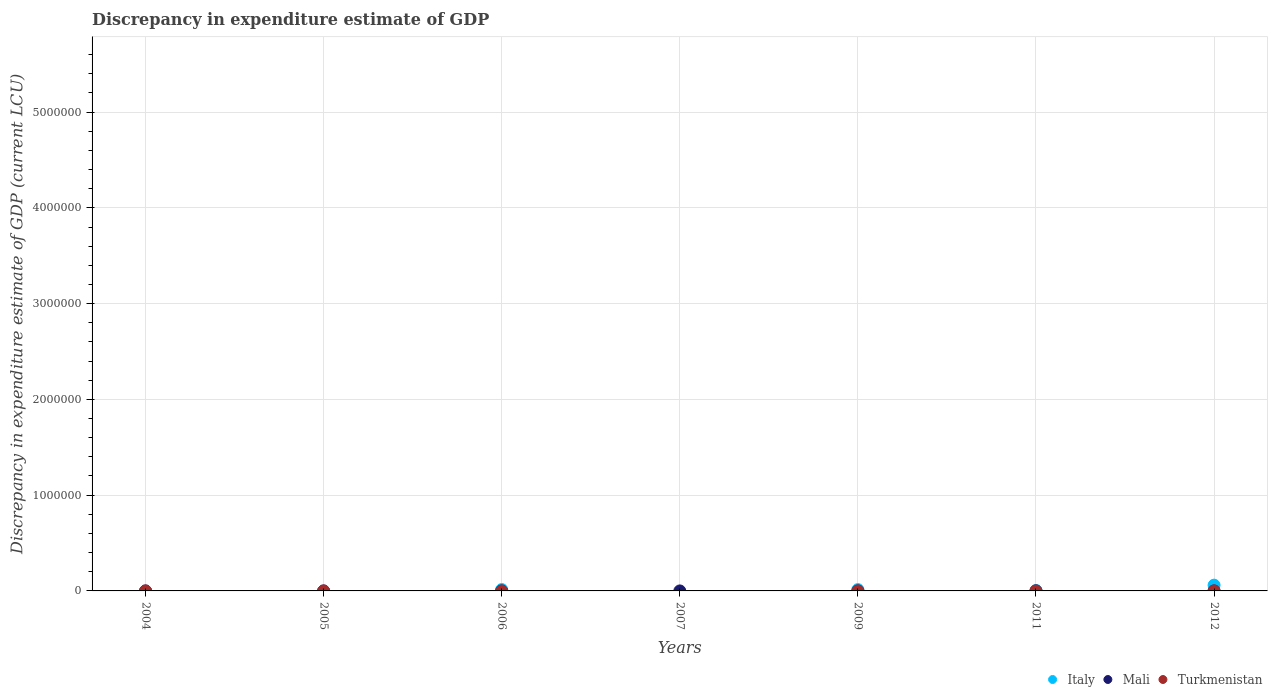Is the number of dotlines equal to the number of legend labels?
Your answer should be very brief. No. What is the discrepancy in expenditure estimate of GDP in Italy in 2012?
Your response must be concise. 6.02e+04. Across all years, what is the maximum discrepancy in expenditure estimate of GDP in Mali?
Provide a succinct answer. 0.01. Across all years, what is the minimum discrepancy in expenditure estimate of GDP in Mali?
Provide a succinct answer. 0. In which year was the discrepancy in expenditure estimate of GDP in Mali maximum?
Ensure brevity in your answer.  2011. What is the total discrepancy in expenditure estimate of GDP in Italy in the graph?
Your answer should be compact. 9.27e+04. What is the difference between the discrepancy in expenditure estimate of GDP in Mali in 2006 and that in 2011?
Offer a terse response. -0.01. What is the difference between the discrepancy in expenditure estimate of GDP in Mali in 2011 and the discrepancy in expenditure estimate of GDP in Italy in 2007?
Give a very brief answer. 0.01. What is the average discrepancy in expenditure estimate of GDP in Turkmenistan per year?
Make the answer very short. 5.66142857142857e-5. In the year 2009, what is the difference between the discrepancy in expenditure estimate of GDP in Italy and discrepancy in expenditure estimate of GDP in Turkmenistan?
Ensure brevity in your answer.  1.36e+04. In how many years, is the discrepancy in expenditure estimate of GDP in Turkmenistan greater than 3400000 LCU?
Your response must be concise. 0. What is the ratio of the discrepancy in expenditure estimate of GDP in Italy in 2011 to that in 2012?
Provide a succinct answer. 0.08. Is the discrepancy in expenditure estimate of GDP in Turkmenistan in 2006 less than that in 2009?
Provide a short and direct response. No. What is the difference between the highest and the second highest discrepancy in expenditure estimate of GDP in Italy?
Offer a terse response. 4.60e+04. What is the difference between the highest and the lowest discrepancy in expenditure estimate of GDP in Italy?
Offer a terse response. 6.02e+04. Does the discrepancy in expenditure estimate of GDP in Italy monotonically increase over the years?
Make the answer very short. No. Is the discrepancy in expenditure estimate of GDP in Mali strictly greater than the discrepancy in expenditure estimate of GDP in Turkmenistan over the years?
Give a very brief answer. No. Is the discrepancy in expenditure estimate of GDP in Mali strictly less than the discrepancy in expenditure estimate of GDP in Italy over the years?
Your response must be concise. No. How many dotlines are there?
Keep it short and to the point. 3. How many years are there in the graph?
Give a very brief answer. 7. Are the values on the major ticks of Y-axis written in scientific E-notation?
Your answer should be compact. No. Does the graph contain grids?
Provide a succinct answer. Yes. How are the legend labels stacked?
Make the answer very short. Horizontal. What is the title of the graph?
Offer a very short reply. Discrepancy in expenditure estimate of GDP. What is the label or title of the X-axis?
Offer a very short reply. Years. What is the label or title of the Y-axis?
Offer a very short reply. Discrepancy in expenditure estimate of GDP (current LCU). What is the Discrepancy in expenditure estimate of GDP (current LCU) in Italy in 2004?
Provide a short and direct response. 0. What is the Discrepancy in expenditure estimate of GDP (current LCU) in Turkmenistan in 2004?
Provide a succinct answer. 0. What is the Discrepancy in expenditure estimate of GDP (current LCU) of Mali in 2005?
Your answer should be compact. 0. What is the Discrepancy in expenditure estimate of GDP (current LCU) of Turkmenistan in 2005?
Provide a short and direct response. 5e-7. What is the Discrepancy in expenditure estimate of GDP (current LCU) of Italy in 2006?
Ensure brevity in your answer.  1.42e+04. What is the Discrepancy in expenditure estimate of GDP (current LCU) of Mali in 2006?
Your answer should be compact. 0. What is the Discrepancy in expenditure estimate of GDP (current LCU) of Turkmenistan in 2006?
Offer a terse response. 9.91e-5. What is the Discrepancy in expenditure estimate of GDP (current LCU) in Italy in 2007?
Give a very brief answer. 0. What is the Discrepancy in expenditure estimate of GDP (current LCU) in Mali in 2007?
Offer a terse response. 0. What is the Discrepancy in expenditure estimate of GDP (current LCU) in Turkmenistan in 2007?
Provide a succinct answer. 0. What is the Discrepancy in expenditure estimate of GDP (current LCU) in Italy in 2009?
Give a very brief answer. 1.36e+04. What is the Discrepancy in expenditure estimate of GDP (current LCU) in Mali in 2009?
Provide a short and direct response. 0. What is the Discrepancy in expenditure estimate of GDP (current LCU) in Turkmenistan in 2009?
Offer a terse response. 9.9e-5. What is the Discrepancy in expenditure estimate of GDP (current LCU) of Italy in 2011?
Ensure brevity in your answer.  4700. What is the Discrepancy in expenditure estimate of GDP (current LCU) of Mali in 2011?
Provide a short and direct response. 0.01. What is the Discrepancy in expenditure estimate of GDP (current LCU) of Turkmenistan in 2011?
Provide a succinct answer. 9.76e-5. What is the Discrepancy in expenditure estimate of GDP (current LCU) of Italy in 2012?
Ensure brevity in your answer.  6.02e+04. What is the Discrepancy in expenditure estimate of GDP (current LCU) of Turkmenistan in 2012?
Your response must be concise. 0. Across all years, what is the maximum Discrepancy in expenditure estimate of GDP (current LCU) in Italy?
Give a very brief answer. 6.02e+04. Across all years, what is the maximum Discrepancy in expenditure estimate of GDP (current LCU) of Mali?
Ensure brevity in your answer.  0.01. Across all years, what is the maximum Discrepancy in expenditure estimate of GDP (current LCU) in Turkmenistan?
Your response must be concise. 0. Across all years, what is the minimum Discrepancy in expenditure estimate of GDP (current LCU) in Mali?
Your answer should be very brief. 0. What is the total Discrepancy in expenditure estimate of GDP (current LCU) in Italy in the graph?
Provide a short and direct response. 9.27e+04. What is the total Discrepancy in expenditure estimate of GDP (current LCU) in Mali in the graph?
Offer a terse response. 0.02. What is the difference between the Discrepancy in expenditure estimate of GDP (current LCU) of Turkmenistan in 2004 and that in 2005?
Offer a terse response. 0. What is the difference between the Discrepancy in expenditure estimate of GDP (current LCU) of Turkmenistan in 2004 and that in 2011?
Make the answer very short. 0. What is the difference between the Discrepancy in expenditure estimate of GDP (current LCU) in Mali in 2005 and that in 2006?
Offer a terse response. 0. What is the difference between the Discrepancy in expenditure estimate of GDP (current LCU) in Turkmenistan in 2005 and that in 2006?
Ensure brevity in your answer.  -0. What is the difference between the Discrepancy in expenditure estimate of GDP (current LCU) in Mali in 2005 and that in 2007?
Keep it short and to the point. 0. What is the difference between the Discrepancy in expenditure estimate of GDP (current LCU) of Turkmenistan in 2005 and that in 2009?
Offer a very short reply. -0. What is the difference between the Discrepancy in expenditure estimate of GDP (current LCU) of Mali in 2005 and that in 2011?
Your response must be concise. -0. What is the difference between the Discrepancy in expenditure estimate of GDP (current LCU) in Turkmenistan in 2005 and that in 2011?
Your response must be concise. -0. What is the difference between the Discrepancy in expenditure estimate of GDP (current LCU) in Mali in 2006 and that in 2007?
Your answer should be very brief. 0. What is the difference between the Discrepancy in expenditure estimate of GDP (current LCU) in Italy in 2006 and that in 2009?
Your answer should be compact. 600. What is the difference between the Discrepancy in expenditure estimate of GDP (current LCU) of Turkmenistan in 2006 and that in 2009?
Offer a terse response. 0. What is the difference between the Discrepancy in expenditure estimate of GDP (current LCU) of Italy in 2006 and that in 2011?
Provide a succinct answer. 9500. What is the difference between the Discrepancy in expenditure estimate of GDP (current LCU) in Mali in 2006 and that in 2011?
Your answer should be very brief. -0.01. What is the difference between the Discrepancy in expenditure estimate of GDP (current LCU) in Italy in 2006 and that in 2012?
Your response must be concise. -4.60e+04. What is the difference between the Discrepancy in expenditure estimate of GDP (current LCU) of Mali in 2007 and that in 2011?
Give a very brief answer. -0.01. What is the difference between the Discrepancy in expenditure estimate of GDP (current LCU) in Italy in 2009 and that in 2011?
Your response must be concise. 8900. What is the difference between the Discrepancy in expenditure estimate of GDP (current LCU) of Turkmenistan in 2009 and that in 2011?
Make the answer very short. 0. What is the difference between the Discrepancy in expenditure estimate of GDP (current LCU) of Italy in 2009 and that in 2012?
Your answer should be very brief. -4.66e+04. What is the difference between the Discrepancy in expenditure estimate of GDP (current LCU) of Italy in 2011 and that in 2012?
Keep it short and to the point. -5.55e+04. What is the difference between the Discrepancy in expenditure estimate of GDP (current LCU) in Mali in 2005 and the Discrepancy in expenditure estimate of GDP (current LCU) in Turkmenistan in 2006?
Your answer should be compact. 0. What is the difference between the Discrepancy in expenditure estimate of GDP (current LCU) of Mali in 2005 and the Discrepancy in expenditure estimate of GDP (current LCU) of Turkmenistan in 2009?
Provide a succinct answer. 0. What is the difference between the Discrepancy in expenditure estimate of GDP (current LCU) of Mali in 2005 and the Discrepancy in expenditure estimate of GDP (current LCU) of Turkmenistan in 2011?
Provide a succinct answer. 0. What is the difference between the Discrepancy in expenditure estimate of GDP (current LCU) in Italy in 2006 and the Discrepancy in expenditure estimate of GDP (current LCU) in Mali in 2007?
Keep it short and to the point. 1.42e+04. What is the difference between the Discrepancy in expenditure estimate of GDP (current LCU) of Italy in 2006 and the Discrepancy in expenditure estimate of GDP (current LCU) of Turkmenistan in 2009?
Your response must be concise. 1.42e+04. What is the difference between the Discrepancy in expenditure estimate of GDP (current LCU) of Mali in 2006 and the Discrepancy in expenditure estimate of GDP (current LCU) of Turkmenistan in 2009?
Offer a terse response. 0. What is the difference between the Discrepancy in expenditure estimate of GDP (current LCU) of Italy in 2006 and the Discrepancy in expenditure estimate of GDP (current LCU) of Mali in 2011?
Ensure brevity in your answer.  1.42e+04. What is the difference between the Discrepancy in expenditure estimate of GDP (current LCU) in Italy in 2006 and the Discrepancy in expenditure estimate of GDP (current LCU) in Turkmenistan in 2011?
Give a very brief answer. 1.42e+04. What is the difference between the Discrepancy in expenditure estimate of GDP (current LCU) in Mali in 2006 and the Discrepancy in expenditure estimate of GDP (current LCU) in Turkmenistan in 2011?
Offer a terse response. 0. What is the difference between the Discrepancy in expenditure estimate of GDP (current LCU) of Mali in 2007 and the Discrepancy in expenditure estimate of GDP (current LCU) of Turkmenistan in 2009?
Provide a short and direct response. 0. What is the difference between the Discrepancy in expenditure estimate of GDP (current LCU) of Mali in 2007 and the Discrepancy in expenditure estimate of GDP (current LCU) of Turkmenistan in 2011?
Your answer should be very brief. 0. What is the difference between the Discrepancy in expenditure estimate of GDP (current LCU) of Italy in 2009 and the Discrepancy in expenditure estimate of GDP (current LCU) of Mali in 2011?
Give a very brief answer. 1.36e+04. What is the difference between the Discrepancy in expenditure estimate of GDP (current LCU) of Italy in 2009 and the Discrepancy in expenditure estimate of GDP (current LCU) of Turkmenistan in 2011?
Offer a very short reply. 1.36e+04. What is the average Discrepancy in expenditure estimate of GDP (current LCU) in Italy per year?
Offer a terse response. 1.32e+04. What is the average Discrepancy in expenditure estimate of GDP (current LCU) of Mali per year?
Your answer should be very brief. 0. What is the average Discrepancy in expenditure estimate of GDP (current LCU) in Turkmenistan per year?
Keep it short and to the point. 0. In the year 2005, what is the difference between the Discrepancy in expenditure estimate of GDP (current LCU) in Mali and Discrepancy in expenditure estimate of GDP (current LCU) in Turkmenistan?
Ensure brevity in your answer.  0. In the year 2006, what is the difference between the Discrepancy in expenditure estimate of GDP (current LCU) of Italy and Discrepancy in expenditure estimate of GDP (current LCU) of Mali?
Offer a terse response. 1.42e+04. In the year 2006, what is the difference between the Discrepancy in expenditure estimate of GDP (current LCU) of Italy and Discrepancy in expenditure estimate of GDP (current LCU) of Turkmenistan?
Provide a short and direct response. 1.42e+04. In the year 2006, what is the difference between the Discrepancy in expenditure estimate of GDP (current LCU) of Mali and Discrepancy in expenditure estimate of GDP (current LCU) of Turkmenistan?
Ensure brevity in your answer.  0. In the year 2009, what is the difference between the Discrepancy in expenditure estimate of GDP (current LCU) of Italy and Discrepancy in expenditure estimate of GDP (current LCU) of Turkmenistan?
Give a very brief answer. 1.36e+04. In the year 2011, what is the difference between the Discrepancy in expenditure estimate of GDP (current LCU) in Italy and Discrepancy in expenditure estimate of GDP (current LCU) in Mali?
Keep it short and to the point. 4699.99. In the year 2011, what is the difference between the Discrepancy in expenditure estimate of GDP (current LCU) of Italy and Discrepancy in expenditure estimate of GDP (current LCU) of Turkmenistan?
Your answer should be very brief. 4700. In the year 2011, what is the difference between the Discrepancy in expenditure estimate of GDP (current LCU) of Mali and Discrepancy in expenditure estimate of GDP (current LCU) of Turkmenistan?
Your response must be concise. 0.01. What is the ratio of the Discrepancy in expenditure estimate of GDP (current LCU) in Turkmenistan in 2004 to that in 2005?
Your answer should be very brief. 200.2. What is the ratio of the Discrepancy in expenditure estimate of GDP (current LCU) in Turkmenistan in 2004 to that in 2006?
Keep it short and to the point. 1.01. What is the ratio of the Discrepancy in expenditure estimate of GDP (current LCU) of Turkmenistan in 2004 to that in 2009?
Provide a succinct answer. 1.01. What is the ratio of the Discrepancy in expenditure estimate of GDP (current LCU) in Turkmenistan in 2004 to that in 2011?
Ensure brevity in your answer.  1.03. What is the ratio of the Discrepancy in expenditure estimate of GDP (current LCU) of Mali in 2005 to that in 2006?
Provide a short and direct response. 1.36. What is the ratio of the Discrepancy in expenditure estimate of GDP (current LCU) in Turkmenistan in 2005 to that in 2006?
Your response must be concise. 0.01. What is the ratio of the Discrepancy in expenditure estimate of GDP (current LCU) in Mali in 2005 to that in 2007?
Ensure brevity in your answer.  2.01. What is the ratio of the Discrepancy in expenditure estimate of GDP (current LCU) of Turkmenistan in 2005 to that in 2009?
Ensure brevity in your answer.  0.01. What is the ratio of the Discrepancy in expenditure estimate of GDP (current LCU) of Mali in 2005 to that in 2011?
Give a very brief answer. 0.5. What is the ratio of the Discrepancy in expenditure estimate of GDP (current LCU) in Turkmenistan in 2005 to that in 2011?
Your answer should be compact. 0.01. What is the ratio of the Discrepancy in expenditure estimate of GDP (current LCU) of Mali in 2006 to that in 2007?
Make the answer very short. 1.48. What is the ratio of the Discrepancy in expenditure estimate of GDP (current LCU) of Italy in 2006 to that in 2009?
Ensure brevity in your answer.  1.04. What is the ratio of the Discrepancy in expenditure estimate of GDP (current LCU) in Turkmenistan in 2006 to that in 2009?
Give a very brief answer. 1. What is the ratio of the Discrepancy in expenditure estimate of GDP (current LCU) in Italy in 2006 to that in 2011?
Your answer should be compact. 3.02. What is the ratio of the Discrepancy in expenditure estimate of GDP (current LCU) in Mali in 2006 to that in 2011?
Offer a terse response. 0.37. What is the ratio of the Discrepancy in expenditure estimate of GDP (current LCU) of Turkmenistan in 2006 to that in 2011?
Your answer should be compact. 1.02. What is the ratio of the Discrepancy in expenditure estimate of GDP (current LCU) in Italy in 2006 to that in 2012?
Give a very brief answer. 0.24. What is the ratio of the Discrepancy in expenditure estimate of GDP (current LCU) of Mali in 2007 to that in 2011?
Your response must be concise. 0.25. What is the ratio of the Discrepancy in expenditure estimate of GDP (current LCU) in Italy in 2009 to that in 2011?
Your answer should be very brief. 2.89. What is the ratio of the Discrepancy in expenditure estimate of GDP (current LCU) in Turkmenistan in 2009 to that in 2011?
Your answer should be compact. 1.01. What is the ratio of the Discrepancy in expenditure estimate of GDP (current LCU) in Italy in 2009 to that in 2012?
Keep it short and to the point. 0.23. What is the ratio of the Discrepancy in expenditure estimate of GDP (current LCU) in Italy in 2011 to that in 2012?
Provide a succinct answer. 0.08. What is the difference between the highest and the second highest Discrepancy in expenditure estimate of GDP (current LCU) in Italy?
Keep it short and to the point. 4.60e+04. What is the difference between the highest and the second highest Discrepancy in expenditure estimate of GDP (current LCU) of Mali?
Make the answer very short. 0. What is the difference between the highest and the lowest Discrepancy in expenditure estimate of GDP (current LCU) of Italy?
Provide a succinct answer. 6.02e+04. What is the difference between the highest and the lowest Discrepancy in expenditure estimate of GDP (current LCU) of Mali?
Offer a terse response. 0.01. 